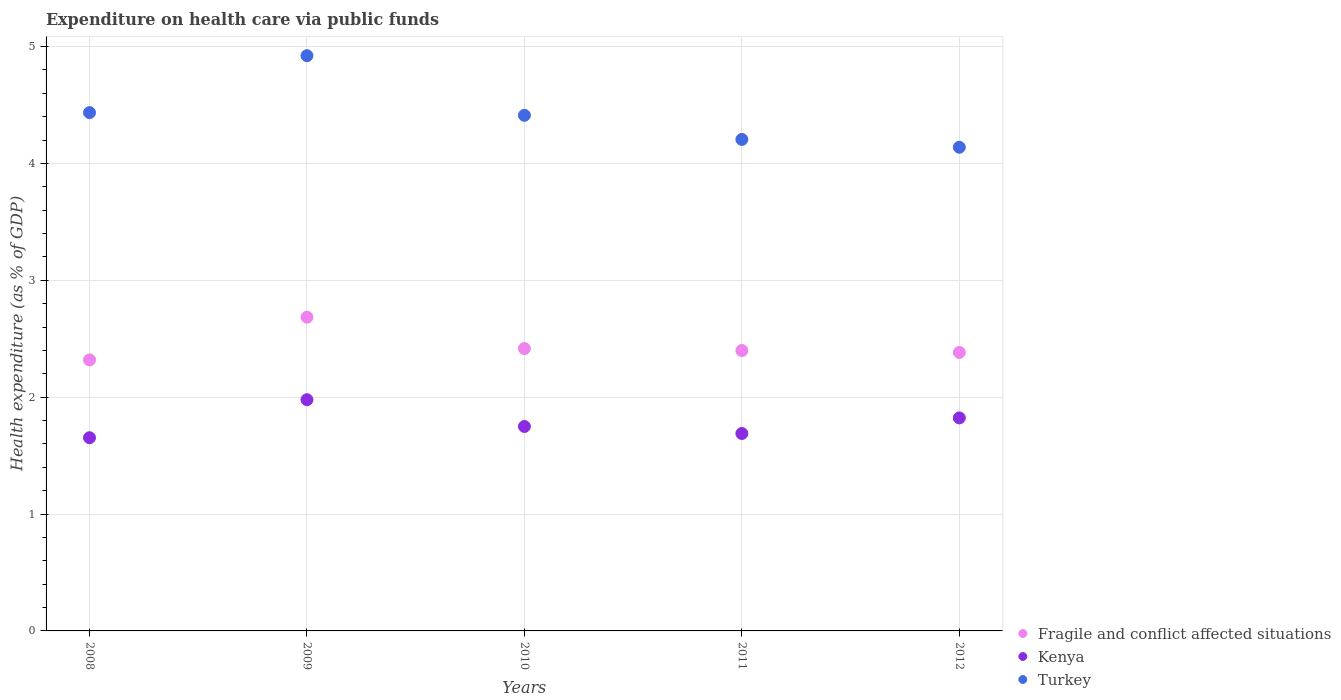How many different coloured dotlines are there?
Your answer should be very brief. 3. What is the expenditure made on health care in Kenya in 2009?
Provide a succinct answer. 1.98. Across all years, what is the maximum expenditure made on health care in Fragile and conflict affected situations?
Your response must be concise. 2.68. Across all years, what is the minimum expenditure made on health care in Kenya?
Offer a very short reply. 1.65. In which year was the expenditure made on health care in Fragile and conflict affected situations maximum?
Make the answer very short. 2009. In which year was the expenditure made on health care in Turkey minimum?
Provide a short and direct response. 2012. What is the total expenditure made on health care in Fragile and conflict affected situations in the graph?
Provide a succinct answer. 12.2. What is the difference between the expenditure made on health care in Fragile and conflict affected situations in 2009 and that in 2012?
Make the answer very short. 0.3. What is the difference between the expenditure made on health care in Kenya in 2008 and the expenditure made on health care in Turkey in 2010?
Keep it short and to the point. -2.76. What is the average expenditure made on health care in Kenya per year?
Offer a very short reply. 1.78. In the year 2011, what is the difference between the expenditure made on health care in Fragile and conflict affected situations and expenditure made on health care in Turkey?
Ensure brevity in your answer.  -1.81. What is the ratio of the expenditure made on health care in Fragile and conflict affected situations in 2008 to that in 2011?
Your answer should be compact. 0.97. Is the difference between the expenditure made on health care in Fragile and conflict affected situations in 2009 and 2012 greater than the difference between the expenditure made on health care in Turkey in 2009 and 2012?
Provide a short and direct response. No. What is the difference between the highest and the second highest expenditure made on health care in Fragile and conflict affected situations?
Give a very brief answer. 0.27. What is the difference between the highest and the lowest expenditure made on health care in Kenya?
Keep it short and to the point. 0.33. In how many years, is the expenditure made on health care in Kenya greater than the average expenditure made on health care in Kenya taken over all years?
Offer a terse response. 2. Is it the case that in every year, the sum of the expenditure made on health care in Kenya and expenditure made on health care in Fragile and conflict affected situations  is greater than the expenditure made on health care in Turkey?
Make the answer very short. No. Is the expenditure made on health care in Kenya strictly greater than the expenditure made on health care in Fragile and conflict affected situations over the years?
Your response must be concise. No. How many dotlines are there?
Keep it short and to the point. 3. How many years are there in the graph?
Keep it short and to the point. 5. Does the graph contain any zero values?
Offer a very short reply. No. Does the graph contain grids?
Ensure brevity in your answer.  Yes. How many legend labels are there?
Give a very brief answer. 3. How are the legend labels stacked?
Your answer should be very brief. Vertical. What is the title of the graph?
Offer a very short reply. Expenditure on health care via public funds. What is the label or title of the X-axis?
Make the answer very short. Years. What is the label or title of the Y-axis?
Your answer should be compact. Health expenditure (as % of GDP). What is the Health expenditure (as % of GDP) of Fragile and conflict affected situations in 2008?
Provide a succinct answer. 2.32. What is the Health expenditure (as % of GDP) in Kenya in 2008?
Keep it short and to the point. 1.65. What is the Health expenditure (as % of GDP) of Turkey in 2008?
Your response must be concise. 4.44. What is the Health expenditure (as % of GDP) of Fragile and conflict affected situations in 2009?
Your response must be concise. 2.68. What is the Health expenditure (as % of GDP) in Kenya in 2009?
Your answer should be very brief. 1.98. What is the Health expenditure (as % of GDP) in Turkey in 2009?
Make the answer very short. 4.92. What is the Health expenditure (as % of GDP) in Fragile and conflict affected situations in 2010?
Give a very brief answer. 2.42. What is the Health expenditure (as % of GDP) of Kenya in 2010?
Ensure brevity in your answer.  1.75. What is the Health expenditure (as % of GDP) in Turkey in 2010?
Ensure brevity in your answer.  4.41. What is the Health expenditure (as % of GDP) of Fragile and conflict affected situations in 2011?
Your answer should be compact. 2.4. What is the Health expenditure (as % of GDP) in Kenya in 2011?
Your response must be concise. 1.69. What is the Health expenditure (as % of GDP) of Turkey in 2011?
Ensure brevity in your answer.  4.21. What is the Health expenditure (as % of GDP) of Fragile and conflict affected situations in 2012?
Provide a succinct answer. 2.38. What is the Health expenditure (as % of GDP) of Kenya in 2012?
Ensure brevity in your answer.  1.82. What is the Health expenditure (as % of GDP) of Turkey in 2012?
Ensure brevity in your answer.  4.14. Across all years, what is the maximum Health expenditure (as % of GDP) of Fragile and conflict affected situations?
Your answer should be compact. 2.68. Across all years, what is the maximum Health expenditure (as % of GDP) of Kenya?
Keep it short and to the point. 1.98. Across all years, what is the maximum Health expenditure (as % of GDP) in Turkey?
Provide a short and direct response. 4.92. Across all years, what is the minimum Health expenditure (as % of GDP) of Fragile and conflict affected situations?
Offer a very short reply. 2.32. Across all years, what is the minimum Health expenditure (as % of GDP) in Kenya?
Provide a succinct answer. 1.65. Across all years, what is the minimum Health expenditure (as % of GDP) of Turkey?
Ensure brevity in your answer.  4.14. What is the total Health expenditure (as % of GDP) of Fragile and conflict affected situations in the graph?
Ensure brevity in your answer.  12.2. What is the total Health expenditure (as % of GDP) in Kenya in the graph?
Provide a succinct answer. 8.89. What is the total Health expenditure (as % of GDP) of Turkey in the graph?
Provide a short and direct response. 22.11. What is the difference between the Health expenditure (as % of GDP) of Fragile and conflict affected situations in 2008 and that in 2009?
Offer a terse response. -0.37. What is the difference between the Health expenditure (as % of GDP) of Kenya in 2008 and that in 2009?
Keep it short and to the point. -0.33. What is the difference between the Health expenditure (as % of GDP) of Turkey in 2008 and that in 2009?
Make the answer very short. -0.49. What is the difference between the Health expenditure (as % of GDP) of Fragile and conflict affected situations in 2008 and that in 2010?
Ensure brevity in your answer.  -0.1. What is the difference between the Health expenditure (as % of GDP) of Kenya in 2008 and that in 2010?
Keep it short and to the point. -0.1. What is the difference between the Health expenditure (as % of GDP) in Turkey in 2008 and that in 2010?
Your response must be concise. 0.02. What is the difference between the Health expenditure (as % of GDP) in Fragile and conflict affected situations in 2008 and that in 2011?
Make the answer very short. -0.08. What is the difference between the Health expenditure (as % of GDP) in Kenya in 2008 and that in 2011?
Offer a very short reply. -0.04. What is the difference between the Health expenditure (as % of GDP) in Turkey in 2008 and that in 2011?
Offer a terse response. 0.23. What is the difference between the Health expenditure (as % of GDP) in Fragile and conflict affected situations in 2008 and that in 2012?
Give a very brief answer. -0.06. What is the difference between the Health expenditure (as % of GDP) of Kenya in 2008 and that in 2012?
Your response must be concise. -0.17. What is the difference between the Health expenditure (as % of GDP) in Turkey in 2008 and that in 2012?
Offer a terse response. 0.3. What is the difference between the Health expenditure (as % of GDP) of Fragile and conflict affected situations in 2009 and that in 2010?
Your response must be concise. 0.27. What is the difference between the Health expenditure (as % of GDP) in Kenya in 2009 and that in 2010?
Your response must be concise. 0.23. What is the difference between the Health expenditure (as % of GDP) of Turkey in 2009 and that in 2010?
Make the answer very short. 0.51. What is the difference between the Health expenditure (as % of GDP) in Fragile and conflict affected situations in 2009 and that in 2011?
Ensure brevity in your answer.  0.29. What is the difference between the Health expenditure (as % of GDP) of Kenya in 2009 and that in 2011?
Ensure brevity in your answer.  0.29. What is the difference between the Health expenditure (as % of GDP) in Turkey in 2009 and that in 2011?
Give a very brief answer. 0.72. What is the difference between the Health expenditure (as % of GDP) of Fragile and conflict affected situations in 2009 and that in 2012?
Your answer should be compact. 0.3. What is the difference between the Health expenditure (as % of GDP) of Kenya in 2009 and that in 2012?
Provide a short and direct response. 0.16. What is the difference between the Health expenditure (as % of GDP) of Turkey in 2009 and that in 2012?
Your response must be concise. 0.78. What is the difference between the Health expenditure (as % of GDP) in Fragile and conflict affected situations in 2010 and that in 2011?
Provide a succinct answer. 0.02. What is the difference between the Health expenditure (as % of GDP) in Kenya in 2010 and that in 2011?
Provide a succinct answer. 0.06. What is the difference between the Health expenditure (as % of GDP) in Turkey in 2010 and that in 2011?
Provide a short and direct response. 0.21. What is the difference between the Health expenditure (as % of GDP) in Fragile and conflict affected situations in 2010 and that in 2012?
Your response must be concise. 0.03. What is the difference between the Health expenditure (as % of GDP) in Kenya in 2010 and that in 2012?
Provide a short and direct response. -0.07. What is the difference between the Health expenditure (as % of GDP) in Turkey in 2010 and that in 2012?
Give a very brief answer. 0.27. What is the difference between the Health expenditure (as % of GDP) in Fragile and conflict affected situations in 2011 and that in 2012?
Your response must be concise. 0.02. What is the difference between the Health expenditure (as % of GDP) in Kenya in 2011 and that in 2012?
Offer a very short reply. -0.13. What is the difference between the Health expenditure (as % of GDP) in Turkey in 2011 and that in 2012?
Give a very brief answer. 0.07. What is the difference between the Health expenditure (as % of GDP) of Fragile and conflict affected situations in 2008 and the Health expenditure (as % of GDP) of Kenya in 2009?
Your answer should be compact. 0.34. What is the difference between the Health expenditure (as % of GDP) in Fragile and conflict affected situations in 2008 and the Health expenditure (as % of GDP) in Turkey in 2009?
Offer a very short reply. -2.6. What is the difference between the Health expenditure (as % of GDP) of Kenya in 2008 and the Health expenditure (as % of GDP) of Turkey in 2009?
Provide a short and direct response. -3.27. What is the difference between the Health expenditure (as % of GDP) in Fragile and conflict affected situations in 2008 and the Health expenditure (as % of GDP) in Kenya in 2010?
Give a very brief answer. 0.57. What is the difference between the Health expenditure (as % of GDP) of Fragile and conflict affected situations in 2008 and the Health expenditure (as % of GDP) of Turkey in 2010?
Your answer should be compact. -2.09. What is the difference between the Health expenditure (as % of GDP) in Kenya in 2008 and the Health expenditure (as % of GDP) in Turkey in 2010?
Provide a short and direct response. -2.76. What is the difference between the Health expenditure (as % of GDP) of Fragile and conflict affected situations in 2008 and the Health expenditure (as % of GDP) of Kenya in 2011?
Keep it short and to the point. 0.63. What is the difference between the Health expenditure (as % of GDP) in Fragile and conflict affected situations in 2008 and the Health expenditure (as % of GDP) in Turkey in 2011?
Ensure brevity in your answer.  -1.89. What is the difference between the Health expenditure (as % of GDP) in Kenya in 2008 and the Health expenditure (as % of GDP) in Turkey in 2011?
Offer a terse response. -2.55. What is the difference between the Health expenditure (as % of GDP) in Fragile and conflict affected situations in 2008 and the Health expenditure (as % of GDP) in Kenya in 2012?
Your answer should be very brief. 0.5. What is the difference between the Health expenditure (as % of GDP) of Fragile and conflict affected situations in 2008 and the Health expenditure (as % of GDP) of Turkey in 2012?
Give a very brief answer. -1.82. What is the difference between the Health expenditure (as % of GDP) of Kenya in 2008 and the Health expenditure (as % of GDP) of Turkey in 2012?
Keep it short and to the point. -2.49. What is the difference between the Health expenditure (as % of GDP) in Fragile and conflict affected situations in 2009 and the Health expenditure (as % of GDP) in Kenya in 2010?
Provide a short and direct response. 0.94. What is the difference between the Health expenditure (as % of GDP) in Fragile and conflict affected situations in 2009 and the Health expenditure (as % of GDP) in Turkey in 2010?
Offer a very short reply. -1.73. What is the difference between the Health expenditure (as % of GDP) in Kenya in 2009 and the Health expenditure (as % of GDP) in Turkey in 2010?
Make the answer very short. -2.43. What is the difference between the Health expenditure (as % of GDP) of Fragile and conflict affected situations in 2009 and the Health expenditure (as % of GDP) of Kenya in 2011?
Offer a terse response. 1. What is the difference between the Health expenditure (as % of GDP) of Fragile and conflict affected situations in 2009 and the Health expenditure (as % of GDP) of Turkey in 2011?
Give a very brief answer. -1.52. What is the difference between the Health expenditure (as % of GDP) of Kenya in 2009 and the Health expenditure (as % of GDP) of Turkey in 2011?
Provide a short and direct response. -2.23. What is the difference between the Health expenditure (as % of GDP) of Fragile and conflict affected situations in 2009 and the Health expenditure (as % of GDP) of Kenya in 2012?
Keep it short and to the point. 0.86. What is the difference between the Health expenditure (as % of GDP) of Fragile and conflict affected situations in 2009 and the Health expenditure (as % of GDP) of Turkey in 2012?
Ensure brevity in your answer.  -1.45. What is the difference between the Health expenditure (as % of GDP) in Kenya in 2009 and the Health expenditure (as % of GDP) in Turkey in 2012?
Your answer should be compact. -2.16. What is the difference between the Health expenditure (as % of GDP) of Fragile and conflict affected situations in 2010 and the Health expenditure (as % of GDP) of Kenya in 2011?
Ensure brevity in your answer.  0.73. What is the difference between the Health expenditure (as % of GDP) of Fragile and conflict affected situations in 2010 and the Health expenditure (as % of GDP) of Turkey in 2011?
Your response must be concise. -1.79. What is the difference between the Health expenditure (as % of GDP) in Kenya in 2010 and the Health expenditure (as % of GDP) in Turkey in 2011?
Give a very brief answer. -2.46. What is the difference between the Health expenditure (as % of GDP) of Fragile and conflict affected situations in 2010 and the Health expenditure (as % of GDP) of Kenya in 2012?
Ensure brevity in your answer.  0.59. What is the difference between the Health expenditure (as % of GDP) in Fragile and conflict affected situations in 2010 and the Health expenditure (as % of GDP) in Turkey in 2012?
Provide a succinct answer. -1.72. What is the difference between the Health expenditure (as % of GDP) of Kenya in 2010 and the Health expenditure (as % of GDP) of Turkey in 2012?
Give a very brief answer. -2.39. What is the difference between the Health expenditure (as % of GDP) of Fragile and conflict affected situations in 2011 and the Health expenditure (as % of GDP) of Kenya in 2012?
Offer a terse response. 0.58. What is the difference between the Health expenditure (as % of GDP) of Fragile and conflict affected situations in 2011 and the Health expenditure (as % of GDP) of Turkey in 2012?
Offer a terse response. -1.74. What is the difference between the Health expenditure (as % of GDP) in Kenya in 2011 and the Health expenditure (as % of GDP) in Turkey in 2012?
Offer a terse response. -2.45. What is the average Health expenditure (as % of GDP) in Fragile and conflict affected situations per year?
Ensure brevity in your answer.  2.44. What is the average Health expenditure (as % of GDP) of Kenya per year?
Your response must be concise. 1.78. What is the average Health expenditure (as % of GDP) in Turkey per year?
Your answer should be very brief. 4.42. In the year 2008, what is the difference between the Health expenditure (as % of GDP) in Fragile and conflict affected situations and Health expenditure (as % of GDP) in Kenya?
Ensure brevity in your answer.  0.67. In the year 2008, what is the difference between the Health expenditure (as % of GDP) of Fragile and conflict affected situations and Health expenditure (as % of GDP) of Turkey?
Give a very brief answer. -2.12. In the year 2008, what is the difference between the Health expenditure (as % of GDP) of Kenya and Health expenditure (as % of GDP) of Turkey?
Your response must be concise. -2.78. In the year 2009, what is the difference between the Health expenditure (as % of GDP) in Fragile and conflict affected situations and Health expenditure (as % of GDP) in Kenya?
Your response must be concise. 0.71. In the year 2009, what is the difference between the Health expenditure (as % of GDP) of Fragile and conflict affected situations and Health expenditure (as % of GDP) of Turkey?
Offer a terse response. -2.24. In the year 2009, what is the difference between the Health expenditure (as % of GDP) in Kenya and Health expenditure (as % of GDP) in Turkey?
Make the answer very short. -2.94. In the year 2010, what is the difference between the Health expenditure (as % of GDP) in Fragile and conflict affected situations and Health expenditure (as % of GDP) in Kenya?
Give a very brief answer. 0.67. In the year 2010, what is the difference between the Health expenditure (as % of GDP) in Fragile and conflict affected situations and Health expenditure (as % of GDP) in Turkey?
Your answer should be compact. -2. In the year 2010, what is the difference between the Health expenditure (as % of GDP) in Kenya and Health expenditure (as % of GDP) in Turkey?
Make the answer very short. -2.66. In the year 2011, what is the difference between the Health expenditure (as % of GDP) of Fragile and conflict affected situations and Health expenditure (as % of GDP) of Kenya?
Your response must be concise. 0.71. In the year 2011, what is the difference between the Health expenditure (as % of GDP) of Fragile and conflict affected situations and Health expenditure (as % of GDP) of Turkey?
Your answer should be very brief. -1.81. In the year 2011, what is the difference between the Health expenditure (as % of GDP) of Kenya and Health expenditure (as % of GDP) of Turkey?
Give a very brief answer. -2.52. In the year 2012, what is the difference between the Health expenditure (as % of GDP) in Fragile and conflict affected situations and Health expenditure (as % of GDP) in Kenya?
Make the answer very short. 0.56. In the year 2012, what is the difference between the Health expenditure (as % of GDP) in Fragile and conflict affected situations and Health expenditure (as % of GDP) in Turkey?
Provide a short and direct response. -1.76. In the year 2012, what is the difference between the Health expenditure (as % of GDP) of Kenya and Health expenditure (as % of GDP) of Turkey?
Ensure brevity in your answer.  -2.32. What is the ratio of the Health expenditure (as % of GDP) in Fragile and conflict affected situations in 2008 to that in 2009?
Offer a terse response. 0.86. What is the ratio of the Health expenditure (as % of GDP) in Kenya in 2008 to that in 2009?
Offer a very short reply. 0.84. What is the ratio of the Health expenditure (as % of GDP) in Turkey in 2008 to that in 2009?
Your response must be concise. 0.9. What is the ratio of the Health expenditure (as % of GDP) in Fragile and conflict affected situations in 2008 to that in 2010?
Offer a very short reply. 0.96. What is the ratio of the Health expenditure (as % of GDP) in Kenya in 2008 to that in 2010?
Your answer should be very brief. 0.95. What is the ratio of the Health expenditure (as % of GDP) of Turkey in 2008 to that in 2010?
Provide a short and direct response. 1.01. What is the ratio of the Health expenditure (as % of GDP) in Fragile and conflict affected situations in 2008 to that in 2011?
Your answer should be compact. 0.97. What is the ratio of the Health expenditure (as % of GDP) of Kenya in 2008 to that in 2011?
Provide a short and direct response. 0.98. What is the ratio of the Health expenditure (as % of GDP) of Turkey in 2008 to that in 2011?
Provide a succinct answer. 1.05. What is the ratio of the Health expenditure (as % of GDP) in Fragile and conflict affected situations in 2008 to that in 2012?
Offer a terse response. 0.97. What is the ratio of the Health expenditure (as % of GDP) of Kenya in 2008 to that in 2012?
Make the answer very short. 0.91. What is the ratio of the Health expenditure (as % of GDP) of Turkey in 2008 to that in 2012?
Provide a succinct answer. 1.07. What is the ratio of the Health expenditure (as % of GDP) of Fragile and conflict affected situations in 2009 to that in 2010?
Your response must be concise. 1.11. What is the ratio of the Health expenditure (as % of GDP) of Kenya in 2009 to that in 2010?
Make the answer very short. 1.13. What is the ratio of the Health expenditure (as % of GDP) in Turkey in 2009 to that in 2010?
Your answer should be very brief. 1.12. What is the ratio of the Health expenditure (as % of GDP) of Fragile and conflict affected situations in 2009 to that in 2011?
Ensure brevity in your answer.  1.12. What is the ratio of the Health expenditure (as % of GDP) in Kenya in 2009 to that in 2011?
Provide a succinct answer. 1.17. What is the ratio of the Health expenditure (as % of GDP) in Turkey in 2009 to that in 2011?
Give a very brief answer. 1.17. What is the ratio of the Health expenditure (as % of GDP) of Fragile and conflict affected situations in 2009 to that in 2012?
Offer a very short reply. 1.13. What is the ratio of the Health expenditure (as % of GDP) in Kenya in 2009 to that in 2012?
Give a very brief answer. 1.09. What is the ratio of the Health expenditure (as % of GDP) of Turkey in 2009 to that in 2012?
Make the answer very short. 1.19. What is the ratio of the Health expenditure (as % of GDP) of Kenya in 2010 to that in 2011?
Offer a very short reply. 1.04. What is the ratio of the Health expenditure (as % of GDP) of Turkey in 2010 to that in 2011?
Your answer should be very brief. 1.05. What is the ratio of the Health expenditure (as % of GDP) of Kenya in 2010 to that in 2012?
Your response must be concise. 0.96. What is the ratio of the Health expenditure (as % of GDP) of Turkey in 2010 to that in 2012?
Your answer should be compact. 1.07. What is the ratio of the Health expenditure (as % of GDP) of Kenya in 2011 to that in 2012?
Offer a very short reply. 0.93. What is the ratio of the Health expenditure (as % of GDP) in Turkey in 2011 to that in 2012?
Provide a succinct answer. 1.02. What is the difference between the highest and the second highest Health expenditure (as % of GDP) in Fragile and conflict affected situations?
Provide a short and direct response. 0.27. What is the difference between the highest and the second highest Health expenditure (as % of GDP) of Kenya?
Give a very brief answer. 0.16. What is the difference between the highest and the second highest Health expenditure (as % of GDP) of Turkey?
Your answer should be very brief. 0.49. What is the difference between the highest and the lowest Health expenditure (as % of GDP) of Fragile and conflict affected situations?
Ensure brevity in your answer.  0.37. What is the difference between the highest and the lowest Health expenditure (as % of GDP) of Kenya?
Keep it short and to the point. 0.33. What is the difference between the highest and the lowest Health expenditure (as % of GDP) of Turkey?
Provide a succinct answer. 0.78. 